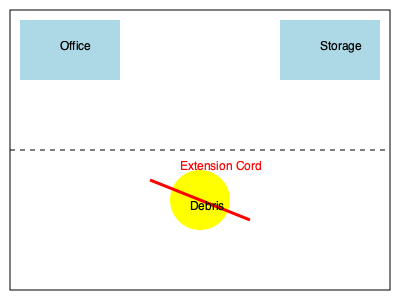As a personal injury lawyer reviewing a construction site floor plan, identify the most significant safety hazard that could lead to a potential lawsuit and explain why it poses a risk. To identify the most significant safety hazard in this construction site floor plan, we need to analyze the elements present:

1. Office and Storage areas: These are standard features and don't present immediate hazards.

2. Debris: The yellow circle in the lower part of the plan represents debris. While this can be a tripping hazard, it's a common issue on construction sites and is usually expected to be managed as part of regular site maintenance.

3. Extension cord: The red line crossing the floor represents an extension cord. This is the most significant hazard for several reasons:

   a) Trip and fall risk: The cord creates a tripping hazard across a large area of the floor.
   b) Electrical hazard: If the cord is damaged or frayed, it could pose an electrocution risk.
   c) Improper use: Extension cords are typically meant for temporary use, not as permanent wiring solutions.
   d) Code violations: Many building codes and OSHA regulations have specific requirements for electrical safety and cord management.
   e) High traffic area: The cord spans across what appears to be the main floor space, increasing the likelihood of accidents.

The extension cord presents the highest risk of injury and potential litigation because:
1. It's an easily preventable hazard.
2. It violates multiple safety standards.
3. It can cause severe injuries (falls or electrocution).
4. Its placement suggests negligence in proper safety management.

As a personal injury lawyer, this hazard would be a focal point in building a case for negligence if an injury occurred.
Answer: Extension cord across the floor 